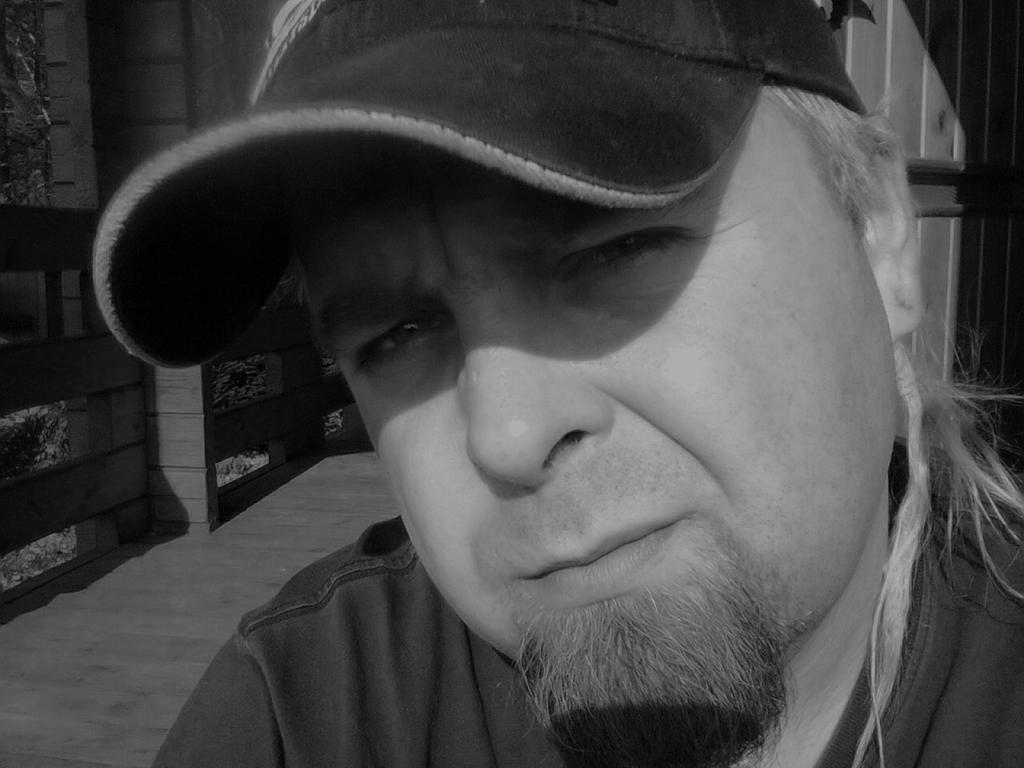Describe this image in one or two sentences. In the picture we can see person wearing cap posing for a photograph and in the background there is wall, there are trees. 